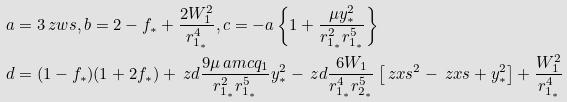Convert formula to latex. <formula><loc_0><loc_0><loc_500><loc_500>a & = 3 \ z w s , b = 2 - f _ { * } + \frac { 2 W ^ { 2 } _ { 1 } } { r ^ { 4 } _ { 1 _ { * } } } , c = - a \left \{ 1 + \frac { \mu { y ^ { 2 } _ { * } } } { { r ^ { 2 } _ { 1 _ { * } } } { r ^ { 5 } _ { 1 _ { * } } } } \right \} \\ d & = ( 1 - f _ { * } ) ( 1 + 2 f _ { * } ) + \ z d { \frac { 9 \mu \ a m c { q _ { 1 } } } { r ^ { 2 } _ { 1 _ { * } } r ^ { 5 } _ { 1 _ { * } } } y ^ { 2 } _ { * } } - \ z d { \frac { 6 W _ { 1 } } { r ^ { 4 } _ { 1 _ { * } } r ^ { 5 } _ { 2 _ { * } } } \left [ \ z x s ^ { 2 } - \ z x s + y ^ { 2 } _ { * } \right ] } + \frac { W ^ { 2 } _ { 1 } } { r ^ { 4 } _ { 1 _ { * } } }</formula> 